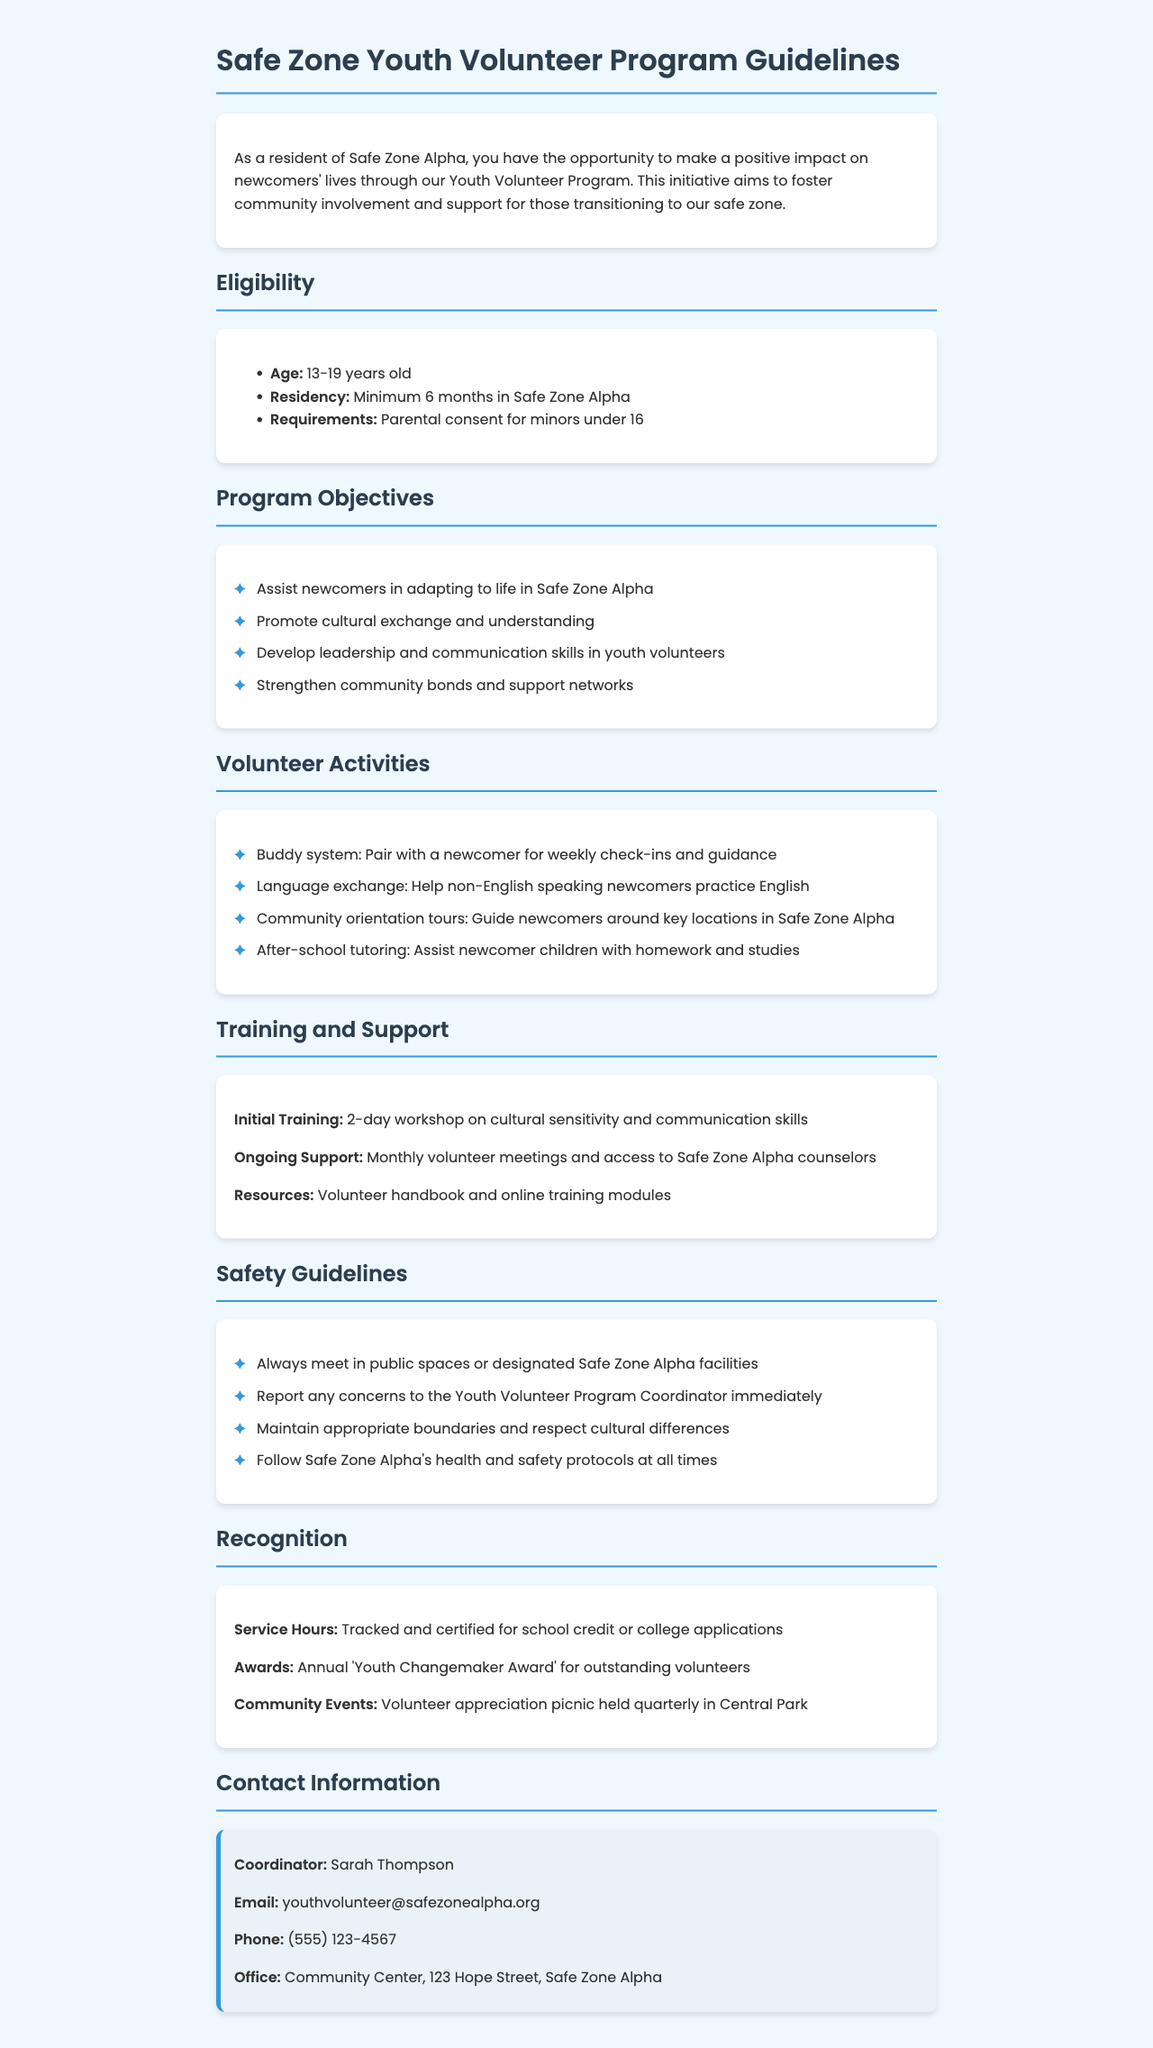What is the age requirement for the Youth Volunteer Program? The age requirement states that participants must be between 13 to 19 years old.
Answer: 13-19 years old What is the minimum residency duration in Safe Zone Alpha? The document specifies that a participant must have a minimum residency of 6 months in Safe Zone Alpha.
Answer: 6 months What is the name of the Youth Volunteer Program Coordinator? The name of the coordinator is mentioned in the contact information section of the document.
Answer: Sarah Thompson What is one of the program objectives? The document lists several objectives, one of them being to assist newcomers in adapting to life in Safe Zone Alpha.
Answer: Assist newcomers in adapting to life in Safe Zone Alpha What type of training is provided to volunteers? The document outlines an initial training workshop focused on cultural sensitivity and communication skills.
Answer: 2-day workshop How are service hours recognized in the program? The document mentions that service hours are tracked and certified for school credit or college applications.
Answer: Certified for school credit or college applications What activity involves non-English speaking newcomers? Helping non-English speaking newcomers practice English is mentioned as a specific volunteer activity in the document.
Answer: Language exchange Where is the Community Center located? The address of the Community Center, which serves as the office for the program, is provided in the contact section.
Answer: 123 Hope Street, Safe Zone Alpha What is an activity where volunteers guide newcomers? The community orientation tours are mentioned as an activity where volunteers guide newcomers around key locations.
Answer: Community orientation tours 